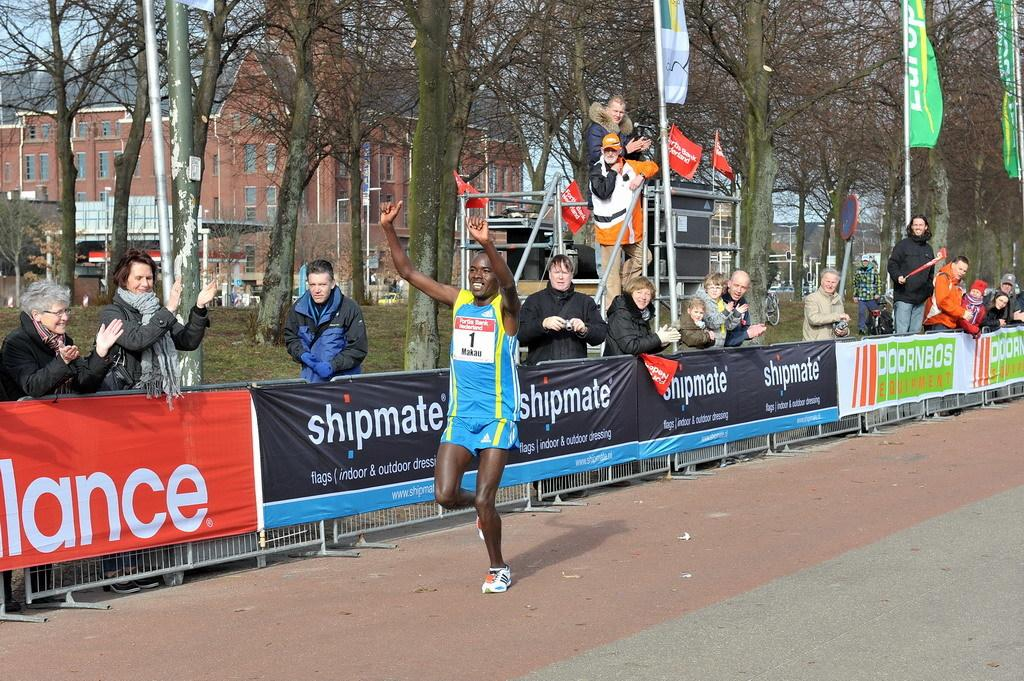What is the main action being performed by the person in the image? There is a person running in the image. What are the other people in the image doing? There are people cheering in the image. What can be seen in the background of the image? There are trees and buildings in the background of the image. What type of school can be seen in the image? There is no school present in the image. What kind of observation can be made about the wilderness in the image? There is no wilderness present in the image; it features a person running and people cheering, as well as trees and buildings in the background. 